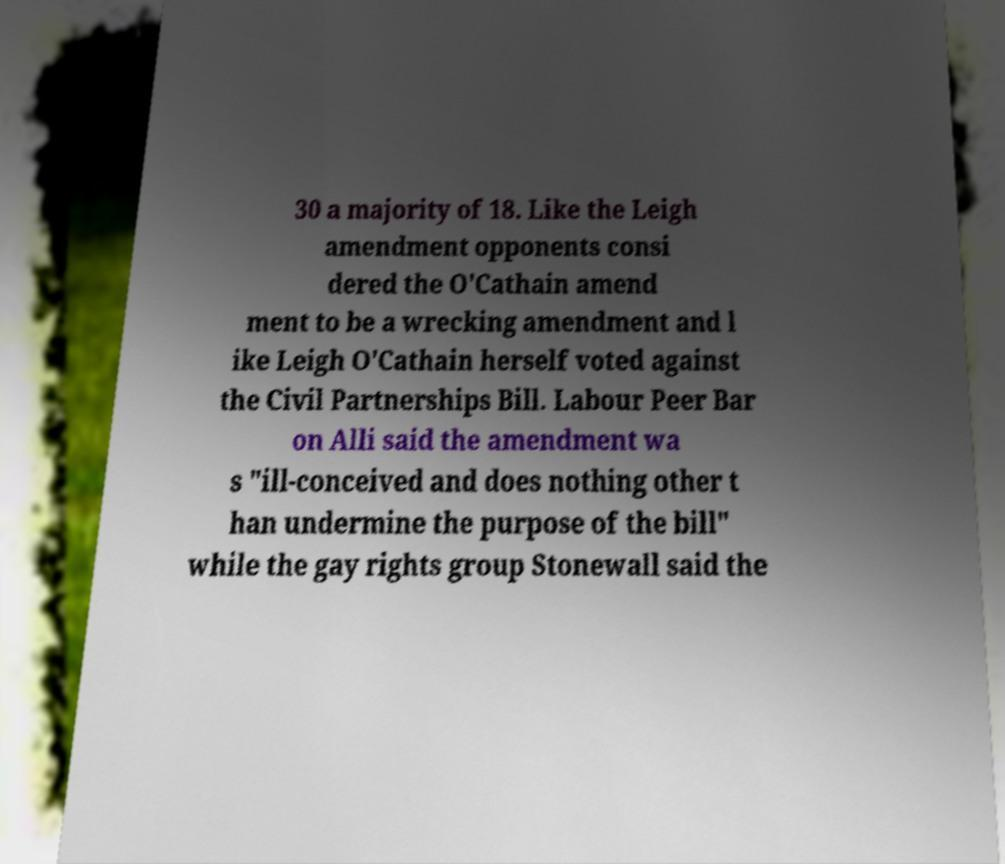What messages or text are displayed in this image? I need them in a readable, typed format. 30 a majority of 18. Like the Leigh amendment opponents consi dered the O'Cathain amend ment to be a wrecking amendment and l ike Leigh O'Cathain herself voted against the Civil Partnerships Bill. Labour Peer Bar on Alli said the amendment wa s "ill-conceived and does nothing other t han undermine the purpose of the bill" while the gay rights group Stonewall said the 